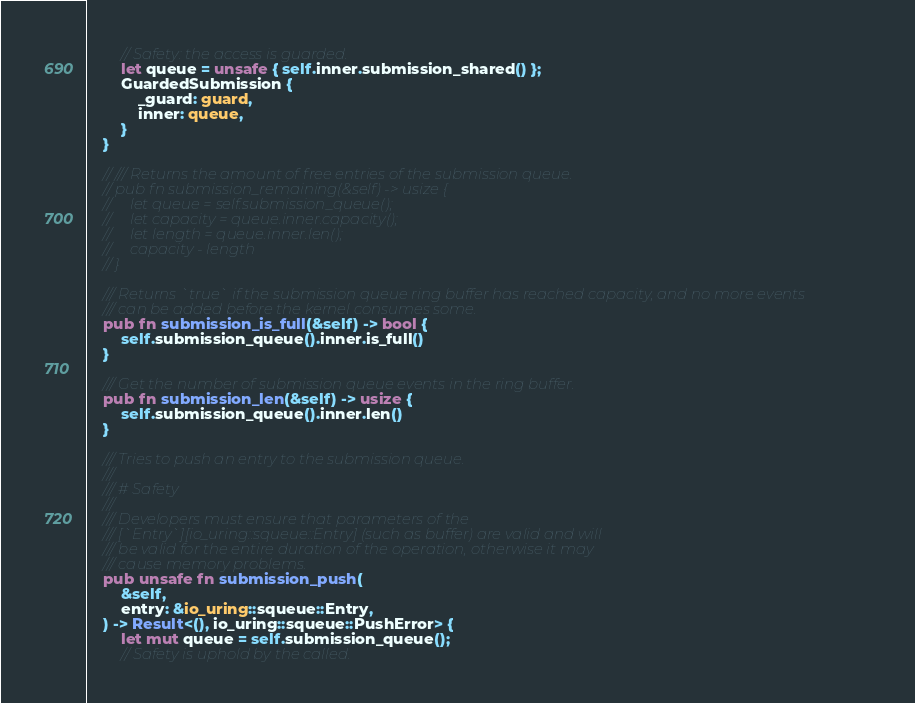Convert code to text. <code><loc_0><loc_0><loc_500><loc_500><_Rust_>        // Safety: the access is guarded.
        let queue = unsafe { self.inner.submission_shared() };
        GuardedSubmission {
            _guard: guard,
            inner: queue,
        }
    }

    // /// Returns the amount of free entries of the submission queue.
    // pub fn submission_remaining(&self) -> usize {
    //     let queue = self.submission_queue();
    //     let capacity = queue.inner.capacity();
    //     let length = queue.inner.len();
    //     capacity - length
    // }

    /// Returns `true` if the submission queue ring buffer has reached capacity, and no more events
    /// can be added before the kernel consumes some.
    pub fn submission_is_full(&self) -> bool {
        self.submission_queue().inner.is_full()
    }

    /// Get the number of submission queue events in the ring buffer.
    pub fn submission_len(&self) -> usize {
        self.submission_queue().inner.len()
    }

    /// Tries to push an entry to the submission queue.
    ///
    /// # Safety
    ///
    /// Developers must ensure that parameters of the
    /// [`Entry`][io_uring::squeue::Entry] (such as buffer) are valid and will
    /// be valid for the entire duration of the operation, otherwise it may
    /// cause memory problems.
    pub unsafe fn submission_push(
        &self,
        entry: &io_uring::squeue::Entry,
    ) -> Result<(), io_uring::squeue::PushError> {
        let mut queue = self.submission_queue();
        // Safety is uphold by the called.</code> 